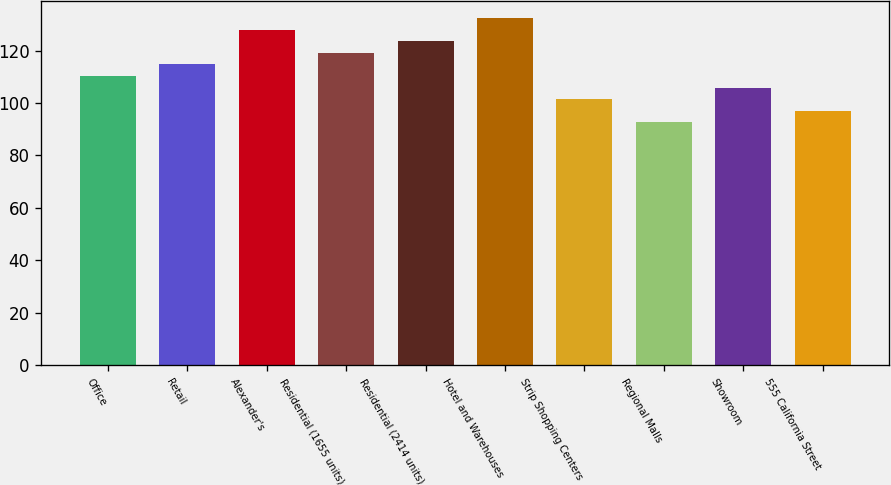<chart> <loc_0><loc_0><loc_500><loc_500><bar_chart><fcel>Office<fcel>Retail<fcel>Alexander's<fcel>Residential (1655 units)<fcel>Residential (2414 units)<fcel>Hotel and Warehouses<fcel>Strip Shopping Centers<fcel>Regional Malls<fcel>Showroom<fcel>555 California Street<nl><fcel>110.34<fcel>114.75<fcel>127.98<fcel>119.16<fcel>123.57<fcel>132.39<fcel>101.52<fcel>92.7<fcel>105.93<fcel>97.11<nl></chart> 